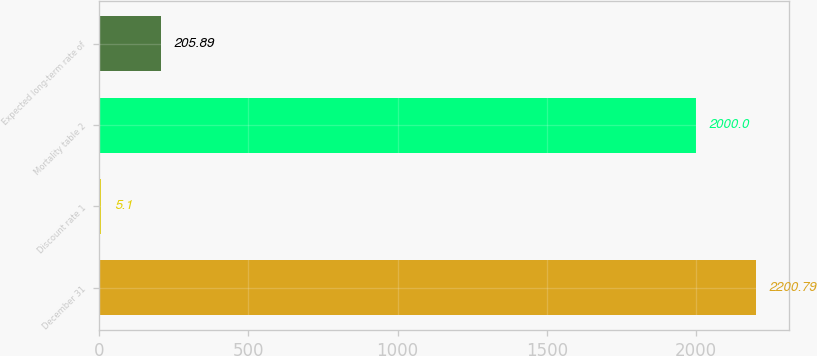<chart> <loc_0><loc_0><loc_500><loc_500><bar_chart><fcel>December 31<fcel>Discount rate 1<fcel>Mortality table 2<fcel>Expected long-term rate of<nl><fcel>2200.79<fcel>5.1<fcel>2000<fcel>205.89<nl></chart> 